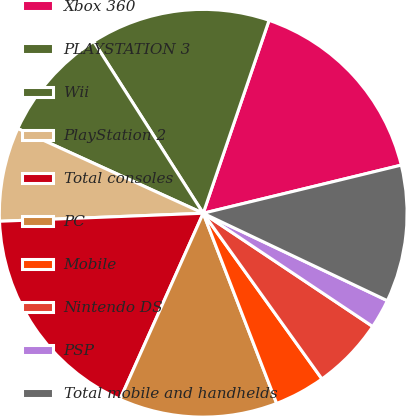Convert chart. <chart><loc_0><loc_0><loc_500><loc_500><pie_chart><fcel>Xbox 360<fcel>PLAYSTATION 3<fcel>Wii<fcel>PlayStation 2<fcel>Total consoles<fcel>PC<fcel>Mobile<fcel>Nintendo DS<fcel>PSP<fcel>Total mobile and handhelds<nl><fcel>15.97%<fcel>14.27%<fcel>9.15%<fcel>7.44%<fcel>17.68%<fcel>12.56%<fcel>4.03%<fcel>5.73%<fcel>2.32%<fcel>10.85%<nl></chart> 